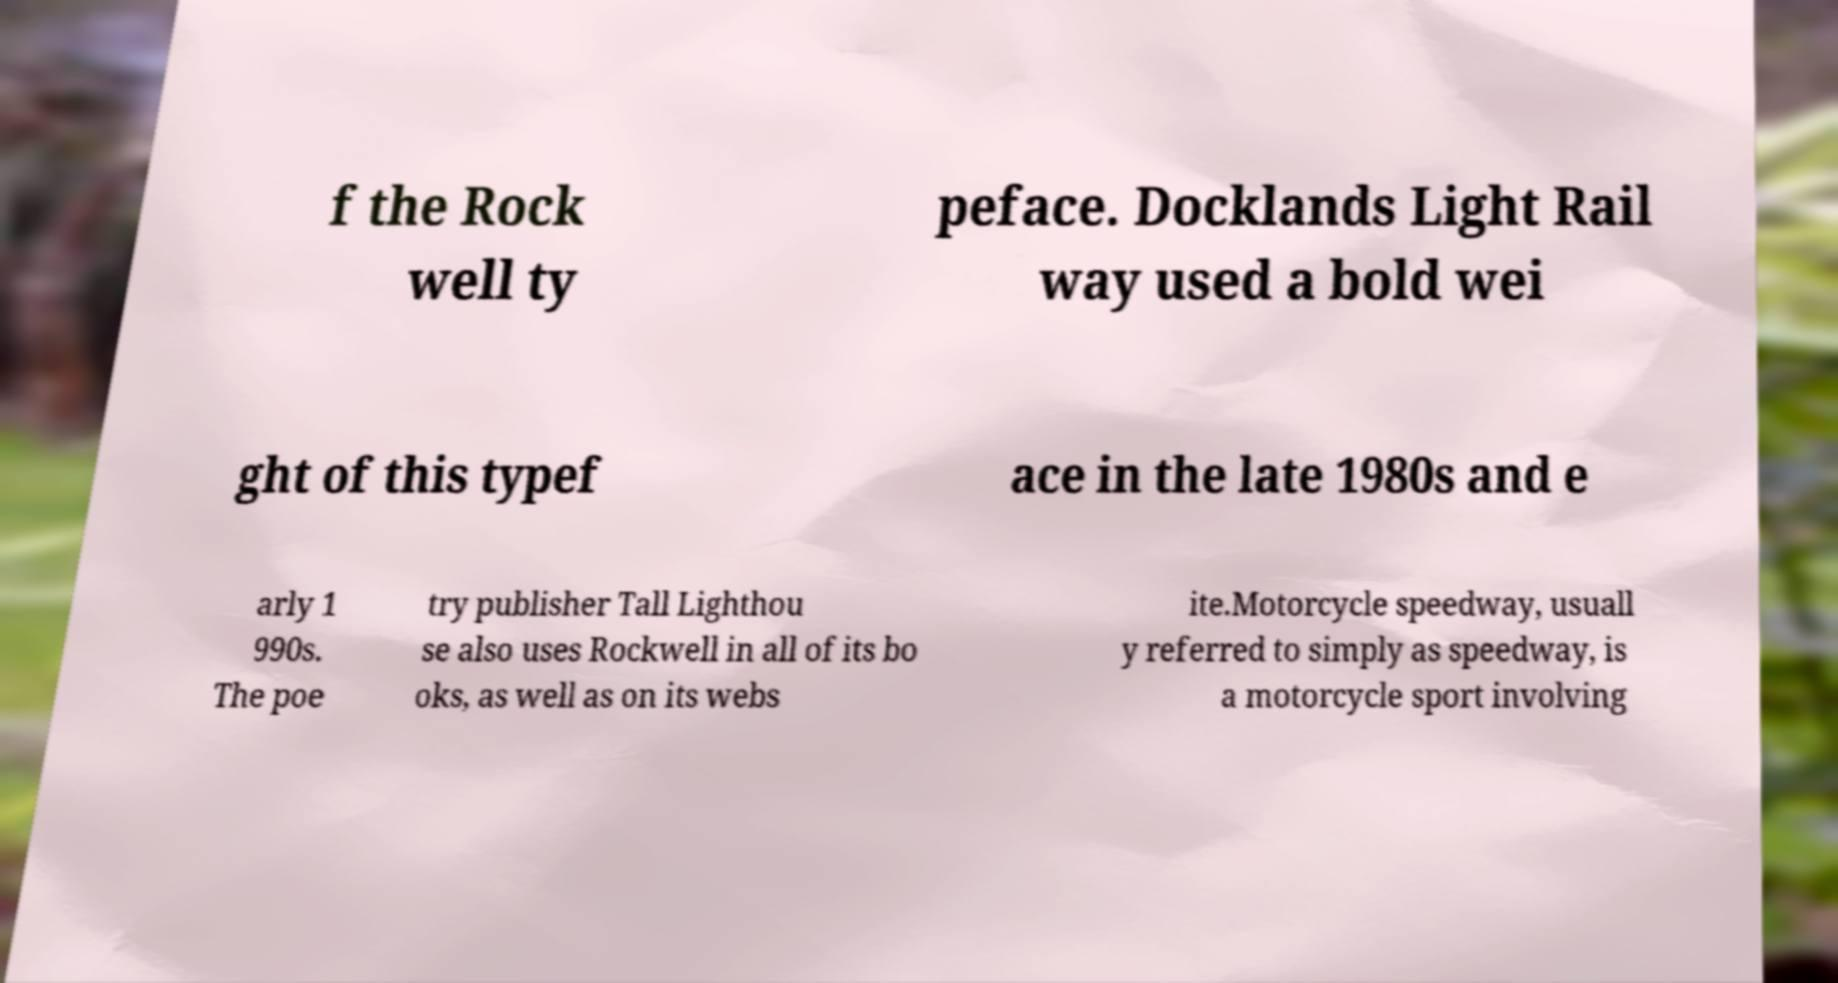There's text embedded in this image that I need extracted. Can you transcribe it verbatim? f the Rock well ty peface. Docklands Light Rail way used a bold wei ght of this typef ace in the late 1980s and e arly 1 990s. The poe try publisher Tall Lighthou se also uses Rockwell in all of its bo oks, as well as on its webs ite.Motorcycle speedway, usuall y referred to simply as speedway, is a motorcycle sport involving 